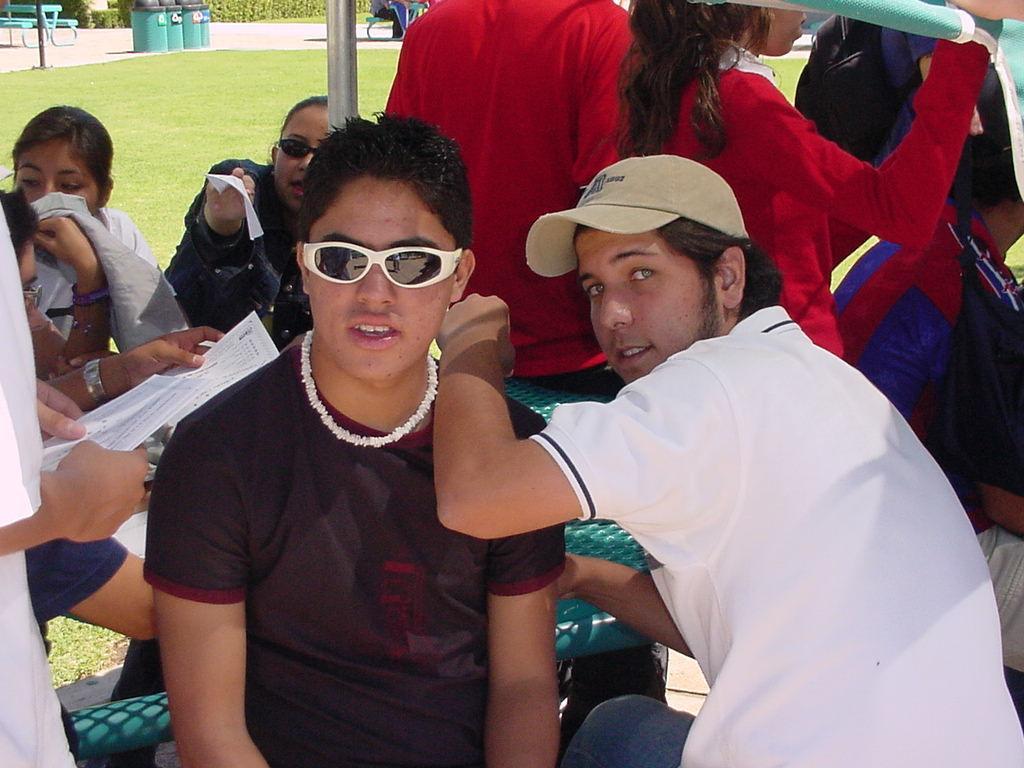How would you summarize this image in a sentence or two? Here I can see few people are sitting. In the foreground two men are looking at the picture. Both are wearing t-shirts. On the left side a person is holding a paper in the hands. In the background, I can see the grass and few dustbins and a bench which are placed on the road. 